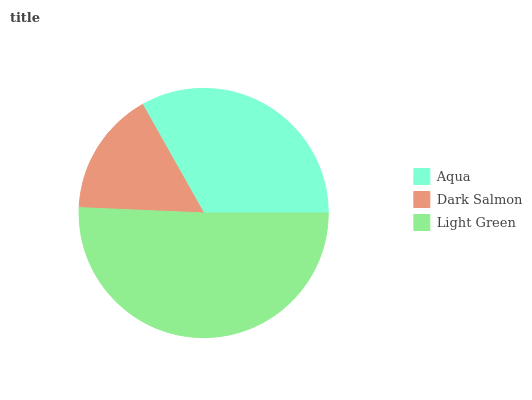Is Dark Salmon the minimum?
Answer yes or no. Yes. Is Light Green the maximum?
Answer yes or no. Yes. Is Light Green the minimum?
Answer yes or no. No. Is Dark Salmon the maximum?
Answer yes or no. No. Is Light Green greater than Dark Salmon?
Answer yes or no. Yes. Is Dark Salmon less than Light Green?
Answer yes or no. Yes. Is Dark Salmon greater than Light Green?
Answer yes or no. No. Is Light Green less than Dark Salmon?
Answer yes or no. No. Is Aqua the high median?
Answer yes or no. Yes. Is Aqua the low median?
Answer yes or no. Yes. Is Dark Salmon the high median?
Answer yes or no. No. Is Light Green the low median?
Answer yes or no. No. 